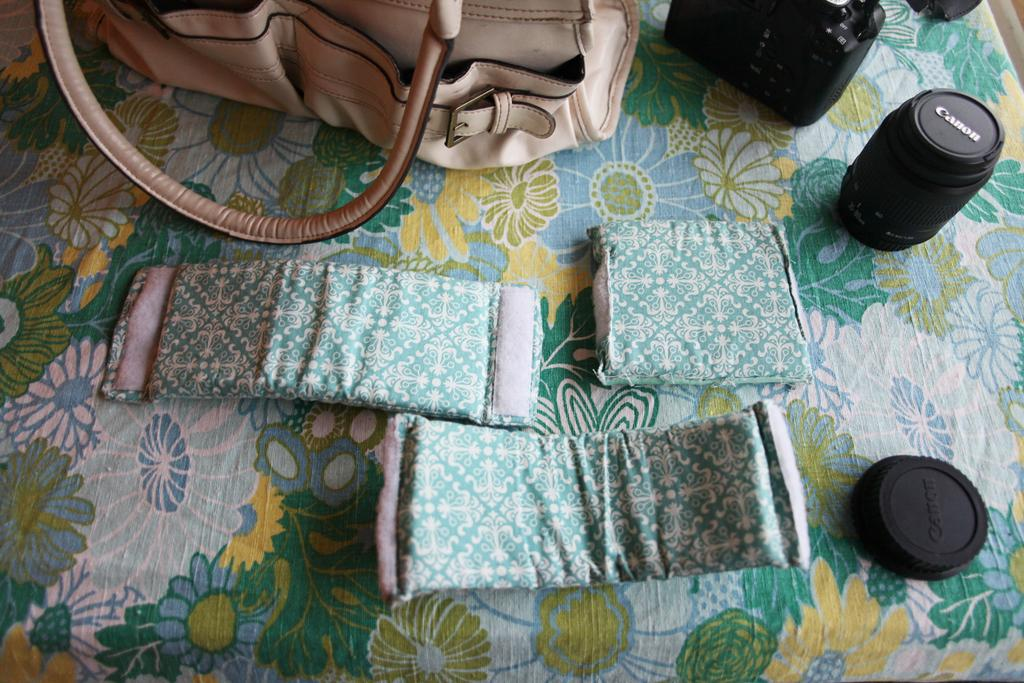What object can be seen in the image that might be used for carrying items? There is a bag in the image that might be used for carrying items. What is the primary subject of the image? The primary subject of the image is a camera. What parts of the camera are visible in the image? There are camera lenses and a camera cap visible in the image. What type of science is being conducted in the image? There is no indication of any scientific activity in the image; it primarily features a bag and a camera. Can you see a tiger in the image? No, there is no tiger present in the image. 